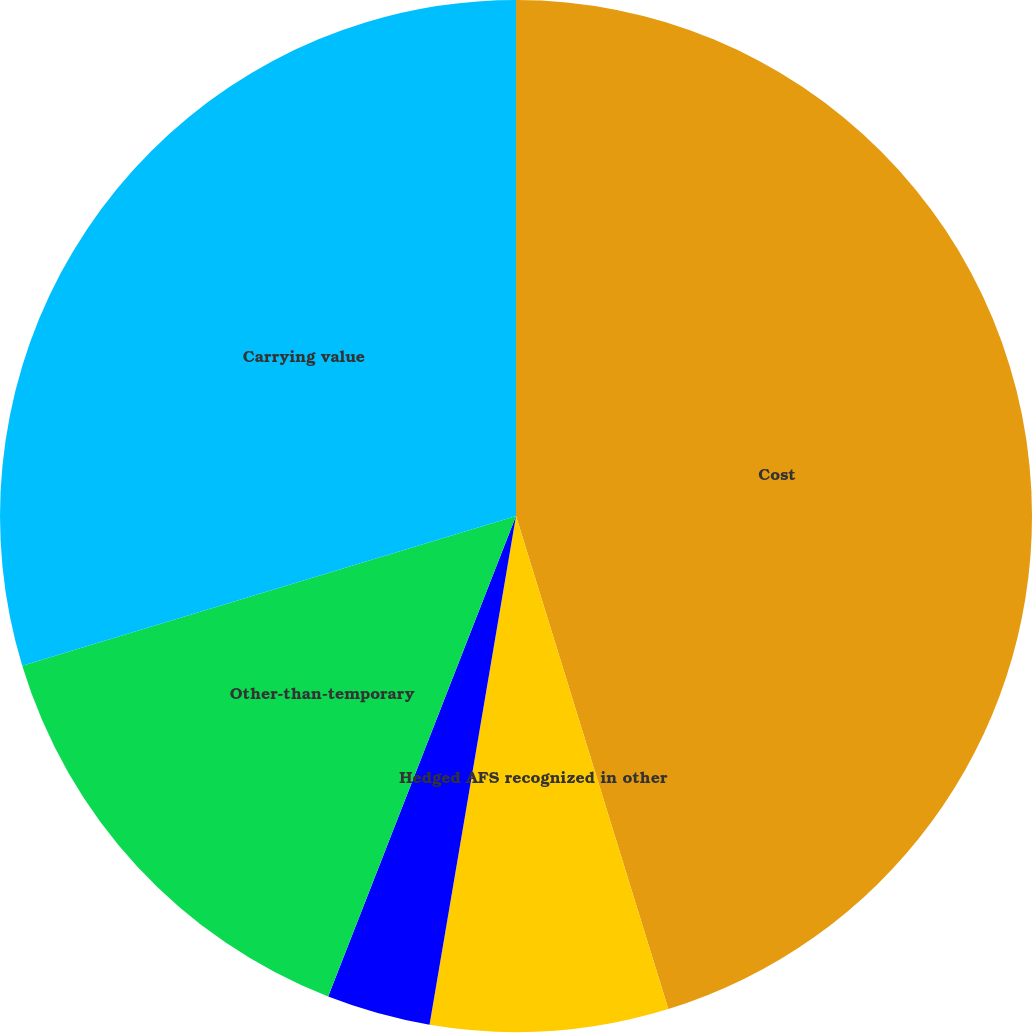Convert chart to OTSL. <chart><loc_0><loc_0><loc_500><loc_500><pie_chart><fcel>Cost<fcel>Hedged AFS recognized in other<fcel>Unhedged AFS recorded in other<fcel>Other-than-temporary<fcel>Carrying value<nl><fcel>45.23%<fcel>7.45%<fcel>3.25%<fcel>14.38%<fcel>29.69%<nl></chart> 